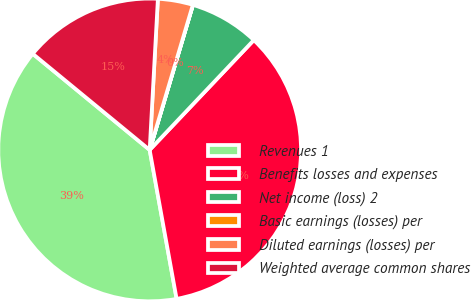Convert chart. <chart><loc_0><loc_0><loc_500><loc_500><pie_chart><fcel>Revenues 1<fcel>Benefits losses and expenses<fcel>Net income (loss) 2<fcel>Basic earnings (losses) per<fcel>Diluted earnings (losses) per<fcel>Weighted average common shares<nl><fcel>38.8%<fcel>35.07%<fcel>7.46%<fcel>0.01%<fcel>3.74%<fcel>14.91%<nl></chart> 